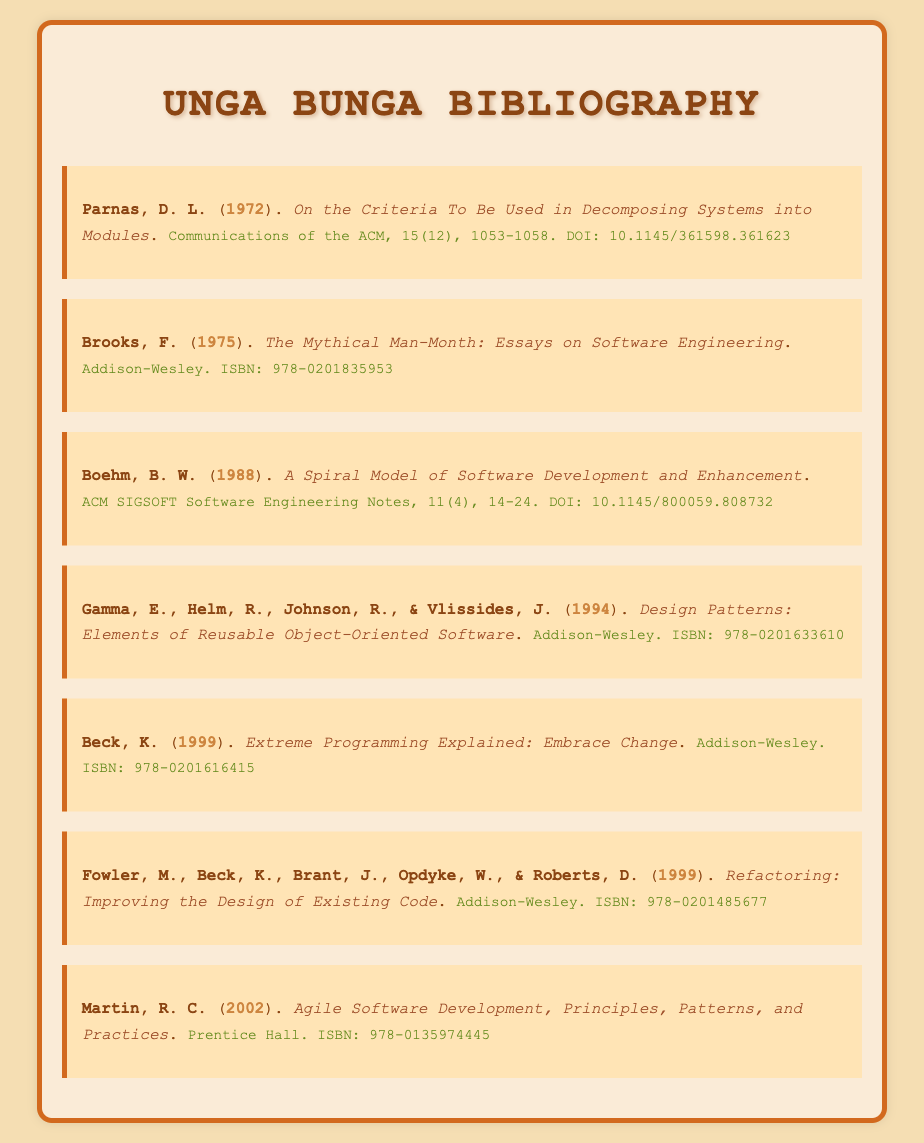What is the first author's name in the bibliography? The first author's name listed in the bibliography is Parnas.
Answer: Parnas What year was "The Mythical Man-Month" published? The year that "The Mythical Man-Month" was published is stated in the document.
Answer: 1975 What is the title of the work by Beck published in 1999? The title of the work by Beck published in 1999 is clearly mentioned in the bibliography.
Answer: Extreme Programming Explained: Embrace Change How many authors are there for the book "Design Patterns"? The number of authors for "Design Patterns" is listed in the bibliography item.
Answer: Four Which book discusses Agile Software Development? The book that discusses Agile Software Development is indicated in the document alongside the author's name.
Answer: Agile Software Development, Principles, Patterns, and Practices What is the DOI for Parnas' 1972 paper? The DOI for Parnas' 1972 paper is included in the details of the bibliography entry.
Answer: 10.1145/361598.361623 What edition of the publication is indicated for "Refactoring"? The edition of "Refactoring" is mentioned within the bibliographic details provided in the document.
Answer: First 